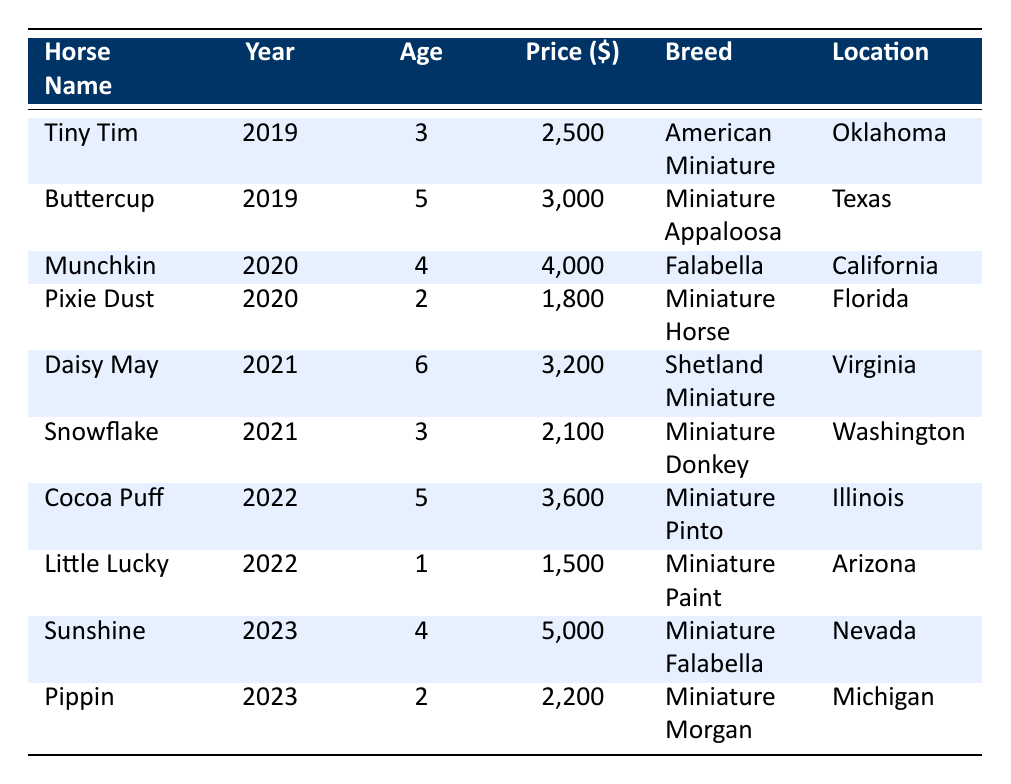What is the price of the horse named "Snowflake"? The table lists "Snowflake" under the year 2021 with a stated price of $2100. I can find this directly in the row corresponding to Snowflake.
Answer: 2100 How many horses were sold in 2022? By counting the entries for the year 2022, there are two horses listed: "Cocoa Puff" and "Little Lucky." This is a straightforward count of the rows for that year.
Answer: 2 What is the average price of the sales in 2020? The two horses sold in 2020 are "Munchkin" priced at $4000 and "Pixie Dust" priced at $1800. The total price is $4000 + $1800 = $5800. There are 2 sales, so the average price is $5800 / 2 = $2900.
Answer: 2900 Did any miniature horses sell for more than $3500 in 2023? Looking at the 2023 entries, "Sunshine" sold for $5000, which is greater than $3500. The answer can be derived by checking the price of horses specifically for that year.
Answer: Yes What is the age difference between the oldest and the youngest horse sold in 2021? In 2021, "Daisy May" is listed as 6 years old and "Snowflake" as 3 years old. To find the difference, subtract the age of the youngest horse from the oldest: 6 - 3 = 3 years.
Answer: 3 What breed of horse sold for the highest price in 2022? The sales in 2022 were "Cocoa Puff" priced at $3600 and "Little Lucky" priced at $1500. The highest price is $3600, corresponding to the breed "Miniature Pinto" sold by "Dreamland Miniatures."
Answer: Miniature Pinto How many unique sellers were involved in the sales from 2019 to 2023? The unique sellers listed are "Happy Hooves Farm," "Sunshine Stables," "Pine Valley Farm," "Meadow Brook Farm," "Greenfield Stables," "Sunny Acres," "Dreamland Miniatures," "Blue Sky Ranch," "Happy Trails Farm," and "Silver Lining Farm," totaling 10 unique sellers from the data.
Answer: 10 What was the total revenue generated from all sales in 2019? The horses sold in 2019 were "Tiny Tim" for $2500 and "Buttercup" for $3000. To find the total revenue, sum these amounts: $2500 + $3000 = $5500.
Answer: 5500 Which horse had the largest age among all entries? Among the entries, "Daisy May" is the oldest at 6 years old in 2021. Comparing all ages listed, methodically checking each entry verifies this is the highest age present in the dataset.
Answer: 6 